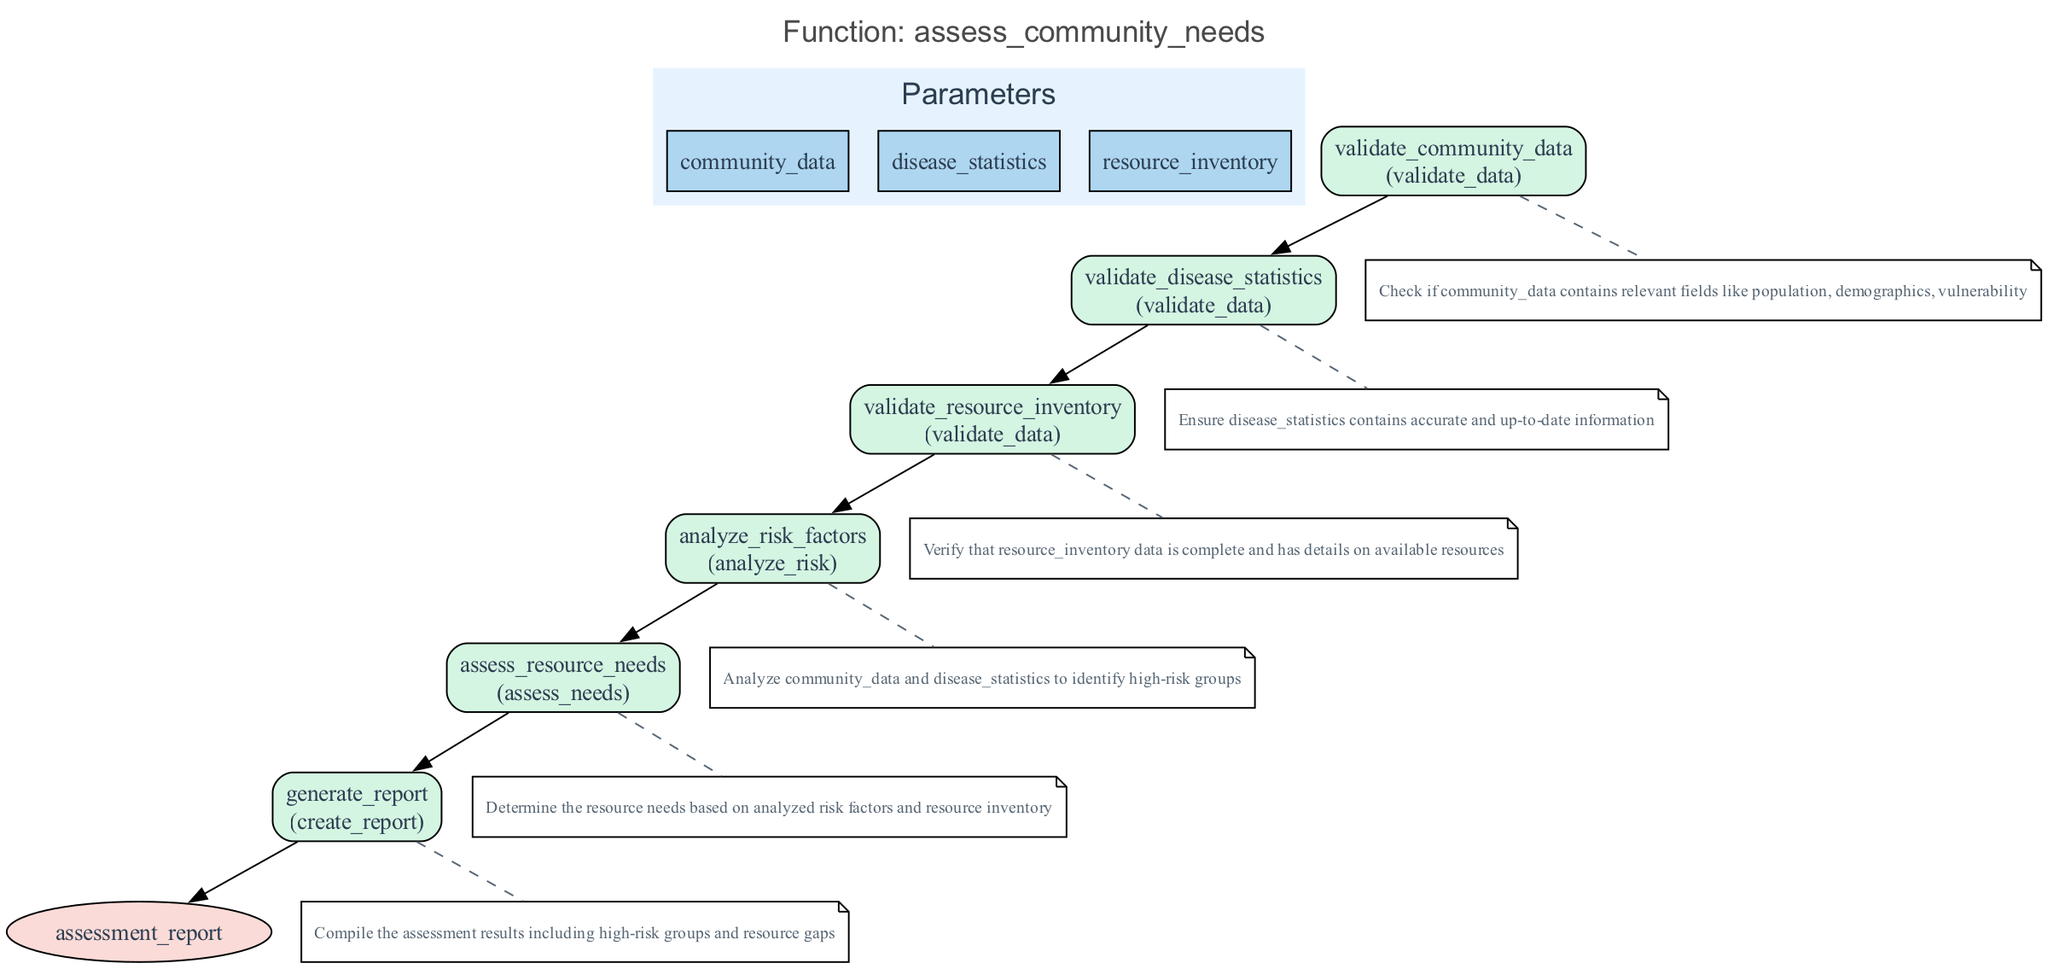What is the name of the function in the diagram? The name of the function is clearly stated at the top of the diagram as "assess_community_needs."
Answer: assess_community_needs How many parameters does the function take? The diagram lists three parameters - community_data, disease_statistics, and resource_inventory, indicating a total of three parameters.
Answer: 3 What is the first step in the function? The first step outlined in the diagram is "validate_community_data," which is the initial action taken in the function.
Answer: validate_community_data What type of node is the final output? The final output node is represented as an ellipse, which is a standard shape used to depict return values in flowcharts.
Answer: ellipse What step follows the validation of resource inventory? After validating the resource inventory in the flowchart, the next step is "analyze_risk_factors." This indicates a sequence of operations regarding community assessment and risk analysis.
Answer: analyze_risk_factors What is the purpose of the step "generate_report"? The purpose of the "generate_report" step, as indicated in the description, is to compile the assessment results, summarizing high-risk groups and resource gaps for review.
Answer: Compile assessment results How many steps are there in total before returning the assessment report? The diagram shows six distinct steps leading up to the return value, including validation, analysis, and assessment stages.
Answer: 6 What happens immediately after analyzing risk factors? Immediately after analyzing risk factors, the flowchart shows the step "assess_resource_needs," where resource requirements are determined based on previously analyzed data.
Answer: assess_resource_needs Which step requires checking the accuracy and timeliness of statistics? The step requiring the verification of the accuracy and timeliness of statistics is "validate_disease_statistics," as specified in the flowchart.
Answer: validate_disease_statistics 